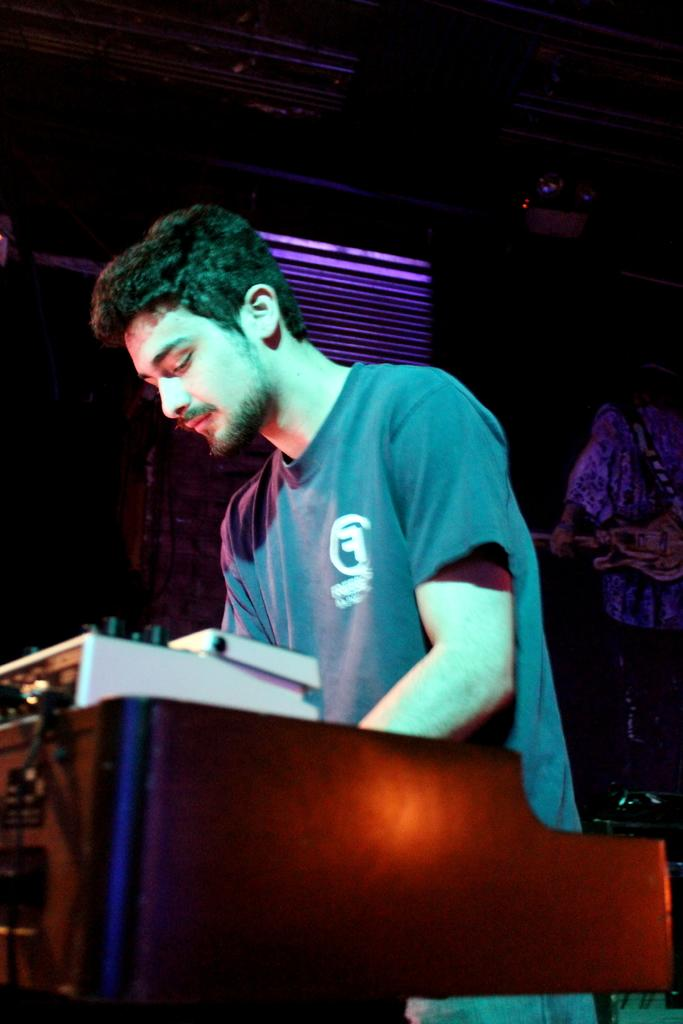What is the man doing in the image? The man is standing in front of a table. What object is on the left side of the table? There is an audio controller on the left side of the table. How would you describe the lighting in the image? The background of the image is dark. Can you see any fairies dancing around the audio controller in the image? No, there are no fairies present in the image. What type of attraction is the man visiting in the image? There is no indication of an attraction in the image; it simply shows a man standing in front of a table with an audio controller. 